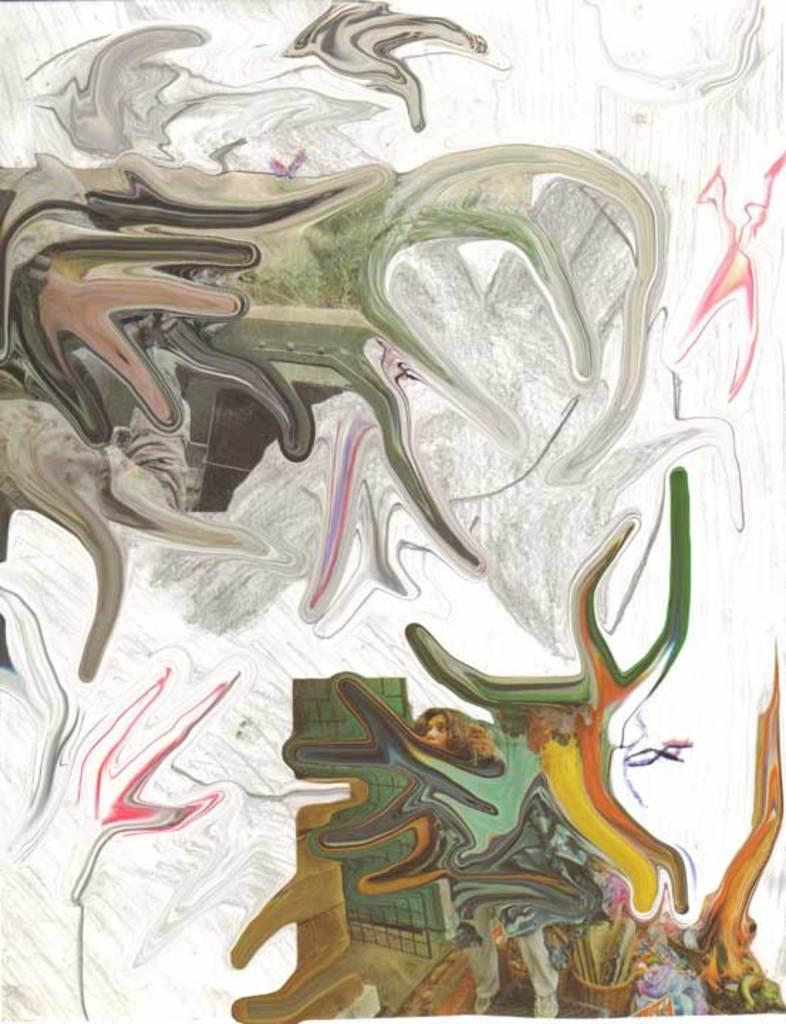What type of artwork is depicted in the image? The image is a painting. What part of a person's body can be seen on the right side of the painting? There is a person's face and legs visible on the right side of the painting. Can you describe the colors and objects in the painting? There are colorful things present in the painting. What type of substance is the person trying to escape from in the painting? There is no indication of a substance or any danger in the painting; it simply depicts a person's face and legs. 